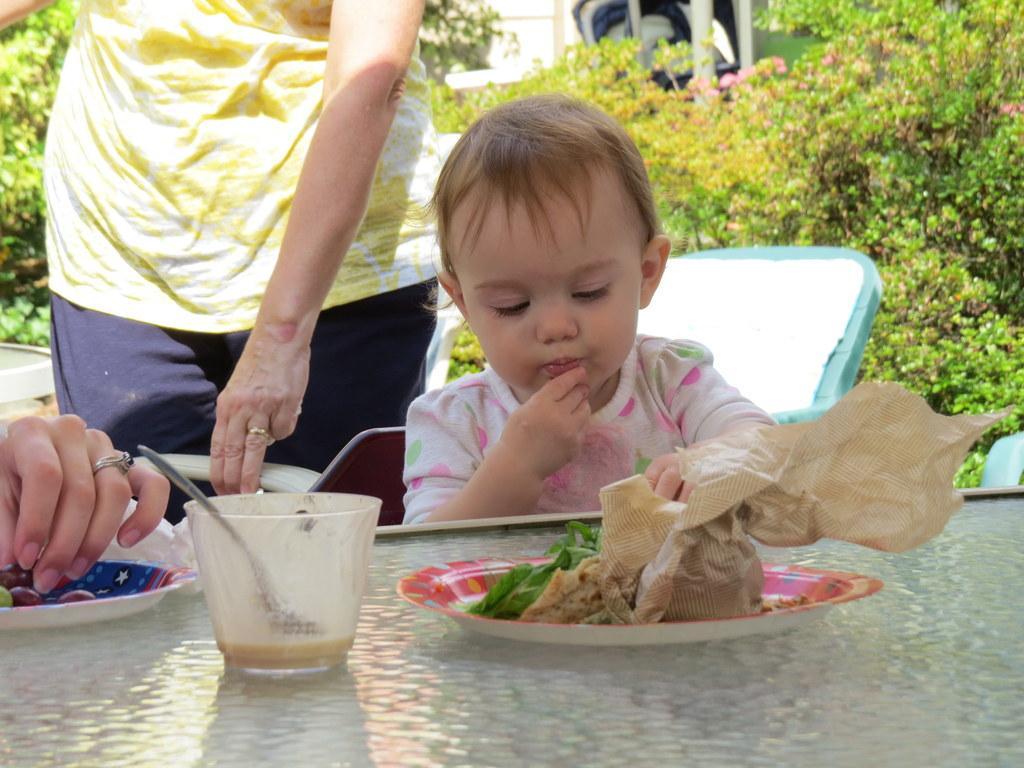Describe this image in one or two sentences. In this image I can see a table in the front and on it I can see a glass, two plates, a paper and different types of food. I can also see a child and one person. In the background I can see a chair like thing, number of plants, few poles, a black colour thing and few other stuffs. On the left side of the image I can see a hand of a person and I can see this person is wearing a ring on the finger. 